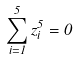<formula> <loc_0><loc_0><loc_500><loc_500>\sum _ { i = 1 } ^ { 5 } z _ { i } ^ { 5 } = 0</formula> 